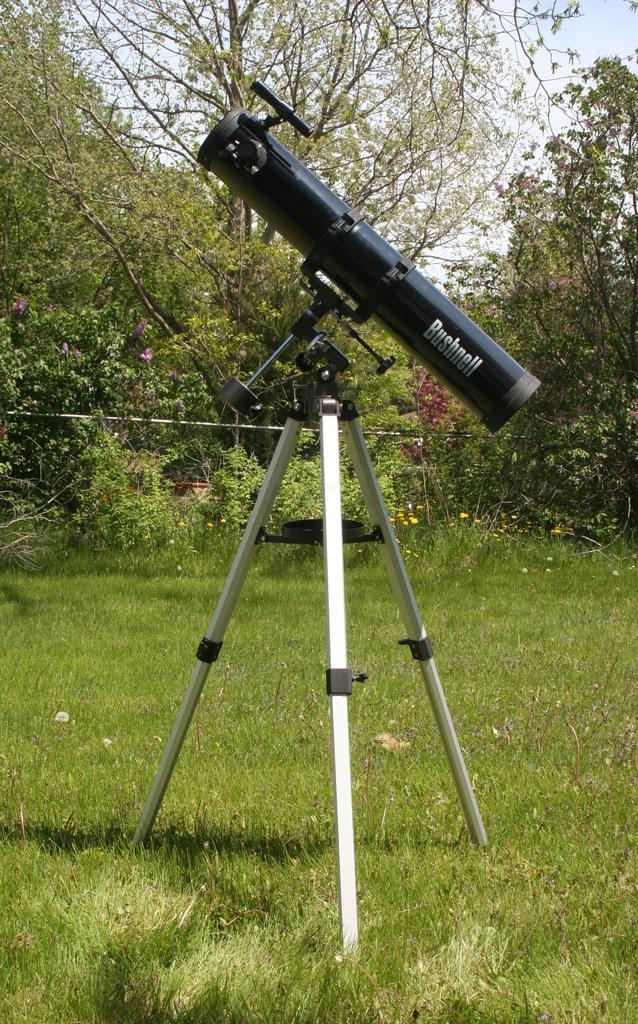What is the main object in the image? There is a binocular on a stand in the image. Where is the stand located? The stand is in the grass. What type of natural environment is visible in the image? There are trees, flowers, and plants in the image. What type of brass instrument can be seen in the image? There is no brass instrument present in the image; it features a binocular on a stand in a natural environment. 